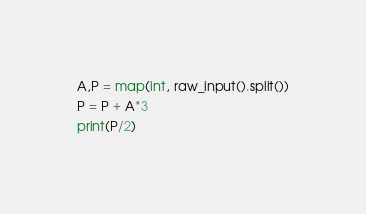Convert code to text. <code><loc_0><loc_0><loc_500><loc_500><_Python_>A,P = map(int, raw_input().split())
P = P + A*3
print(P/2)</code> 